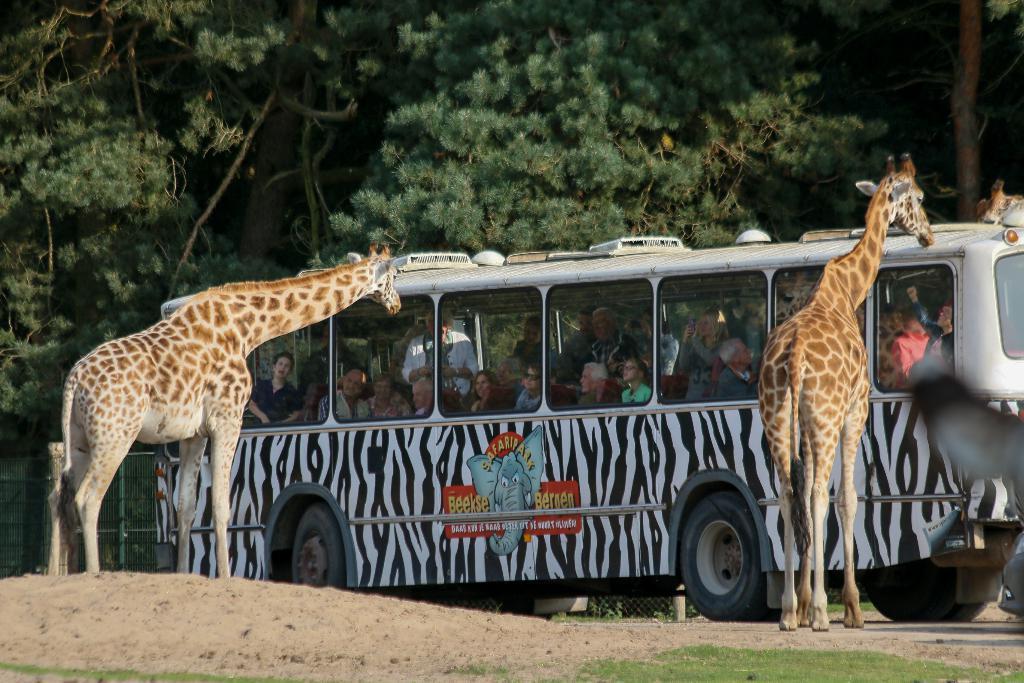Please provide a concise description of this image. In this picture we can see a bus with a group of people in it, two giraffes standing on the ground, grass, fence and in the background we can see trees. 